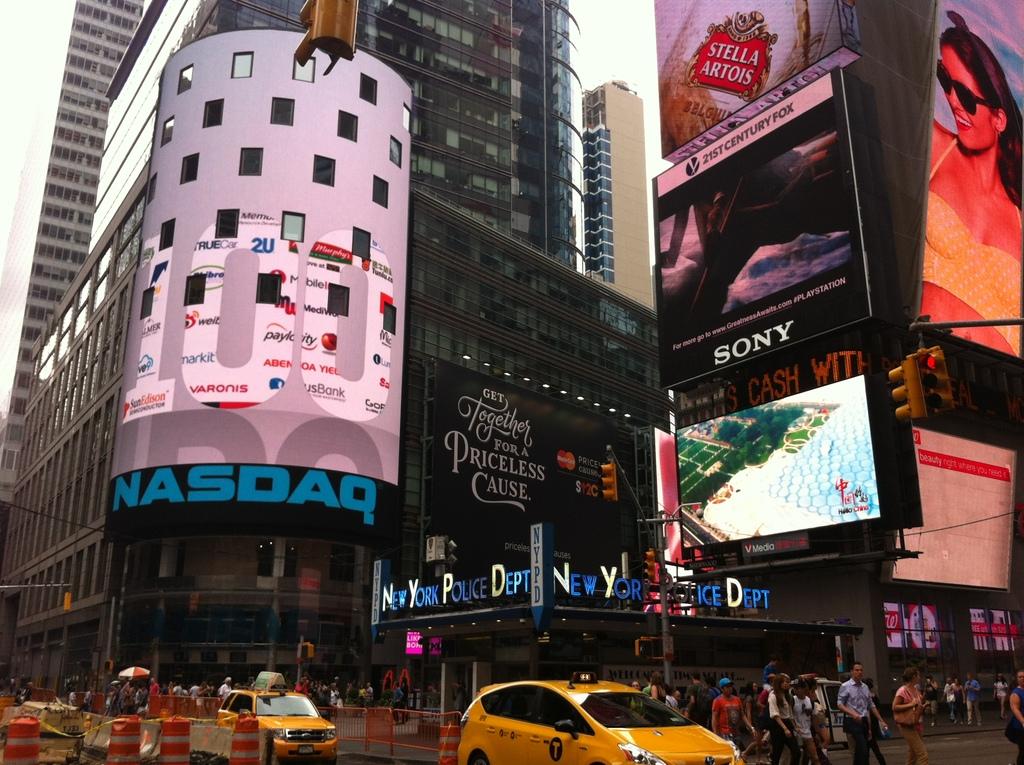What are one of the large brands shown here?
Your response must be concise. Sony. What brand is being advertised on the highest billboard?
Your answer should be compact. Stella artois. 